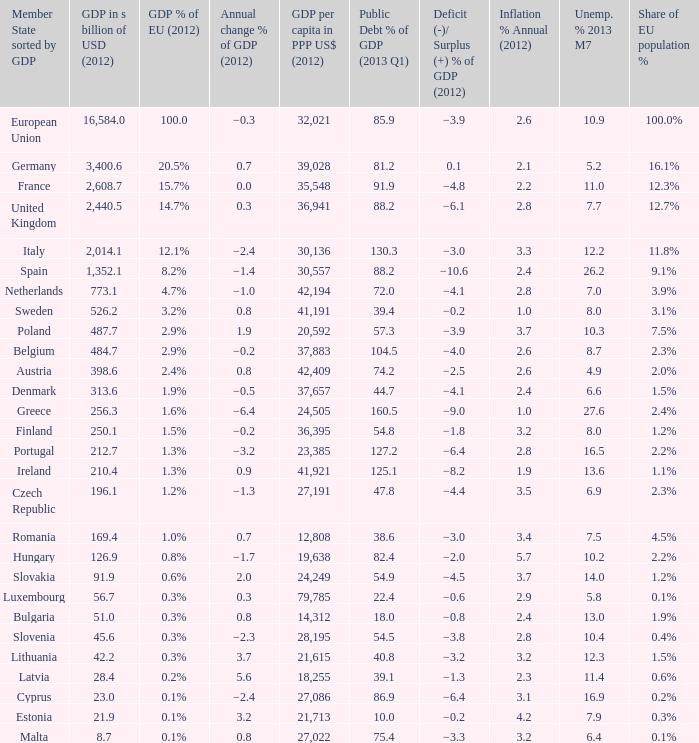What is the average public debt % of GDP in 2013 Q1 of the country with a member slate sorted by GDP of Czech Republic and a GDP per capita in PPP US dollars in 2012 greater than 27,191? None. Can you parse all the data within this table? {'header': ['Member State sorted by GDP', 'GDP in s billion of USD (2012)', 'GDP % of EU (2012)', 'Annual change % of GDP (2012)', 'GDP per capita in PPP US$ (2012)', 'Public Debt % of GDP (2013 Q1)', 'Deficit (-)/ Surplus (+) % of GDP (2012)', 'Inflation % Annual (2012)', 'Unemp. % 2013 M7', 'Share of EU population %'], 'rows': [['European Union', '16,584.0', '100.0', '−0.3', '32,021', '85.9', '−3.9', '2.6', '10.9', '100.0%'], ['Germany', '3,400.6', '20.5%', '0.7', '39,028', '81.2', '0.1', '2.1', '5.2', '16.1%'], ['France', '2,608.7', '15.7%', '0.0', '35,548', '91.9', '−4.8', '2.2', '11.0', '12.3%'], ['United Kingdom', '2,440.5', '14.7%', '0.3', '36,941', '88.2', '−6.1', '2.8', '7.7', '12.7%'], ['Italy', '2,014.1', '12.1%', '−2.4', '30,136', '130.3', '−3.0', '3.3', '12.2', '11.8%'], ['Spain', '1,352.1', '8.2%', '−1.4', '30,557', '88.2', '−10.6', '2.4', '26.2', '9.1%'], ['Netherlands', '773.1', '4.7%', '−1.0', '42,194', '72.0', '−4.1', '2.8', '7.0', '3.9%'], ['Sweden', '526.2', '3.2%', '0.8', '41,191', '39.4', '−0.2', '1.0', '8.0', '3.1%'], ['Poland', '487.7', '2.9%', '1.9', '20,592', '57.3', '−3.9', '3.7', '10.3', '7.5%'], ['Belgium', '484.7', '2.9%', '−0.2', '37,883', '104.5', '−4.0', '2.6', '8.7', '2.3%'], ['Austria', '398.6', '2.4%', '0.8', '42,409', '74.2', '−2.5', '2.6', '4.9', '2.0%'], ['Denmark', '313.6', '1.9%', '−0.5', '37,657', '44.7', '−4.1', '2.4', '6.6', '1.5%'], ['Greece', '256.3', '1.6%', '−6.4', '24,505', '160.5', '−9.0', '1.0', '27.6', '2.4%'], ['Finland', '250.1', '1.5%', '−0.2', '36,395', '54.8', '−1.8', '3.2', '8.0', '1.2%'], ['Portugal', '212.7', '1.3%', '−3.2', '23,385', '127.2', '−6.4', '2.8', '16.5', '2.2%'], ['Ireland', '210.4', '1.3%', '0.9', '41,921', '125.1', '−8.2', '1.9', '13.6', '1.1%'], ['Czech Republic', '196.1', '1.2%', '−1.3', '27,191', '47.8', '−4.4', '3.5', '6.9', '2.3%'], ['Romania', '169.4', '1.0%', '0.7', '12,808', '38.6', '−3.0', '3.4', '7.5', '4.5%'], ['Hungary', '126.9', '0.8%', '−1.7', '19,638', '82.4', '−2.0', '5.7', '10.2', '2.2%'], ['Slovakia', '91.9', '0.6%', '2.0', '24,249', '54.9', '−4.5', '3.7', '14.0', '1.2%'], ['Luxembourg', '56.7', '0.3%', '0.3', '79,785', '22.4', '−0.6', '2.9', '5.8', '0.1%'], ['Bulgaria', '51.0', '0.3%', '0.8', '14,312', '18.0', '−0.8', '2.4', '13.0', '1.9%'], ['Slovenia', '45.6', '0.3%', '−2.3', '28,195', '54.5', '−3.8', '2.8', '10.4', '0.4%'], ['Lithuania', '42.2', '0.3%', '3.7', '21,615', '40.8', '−3.2', '3.2', '12.3', '1.5%'], ['Latvia', '28.4', '0.2%', '5.6', '18,255', '39.1', '−1.3', '2.3', '11.4', '0.6%'], ['Cyprus', '23.0', '0.1%', '−2.4', '27,086', '86.9', '−6.4', '3.1', '16.9', '0.2%'], ['Estonia', '21.9', '0.1%', '3.2', '21,713', '10.0', '−0.2', '4.2', '7.9', '0.3%'], ['Malta', '8.7', '0.1%', '0.8', '27,022', '75.4', '−3.3', '3.2', '6.4', '0.1%']]} 